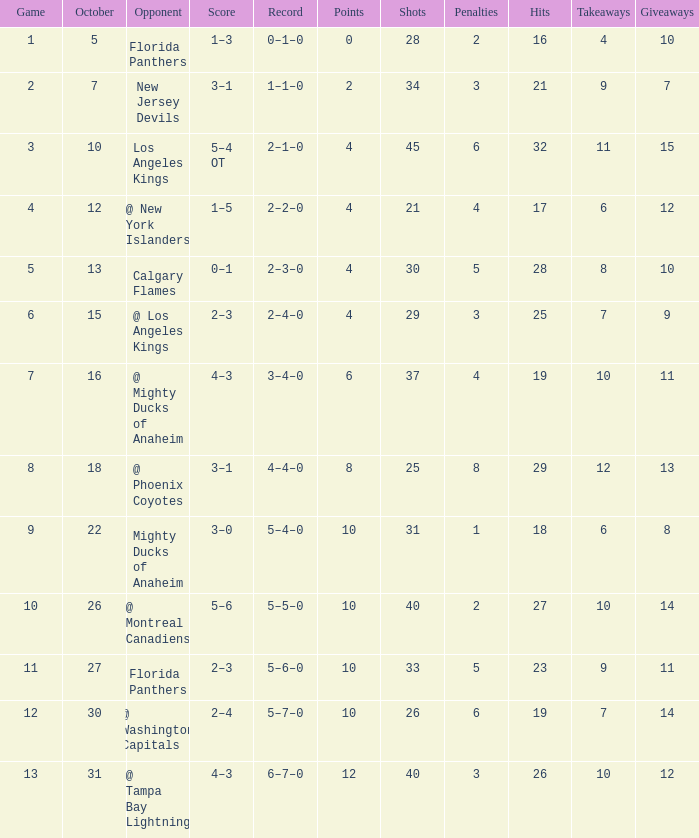What team has a score of 11 5–6–0. 